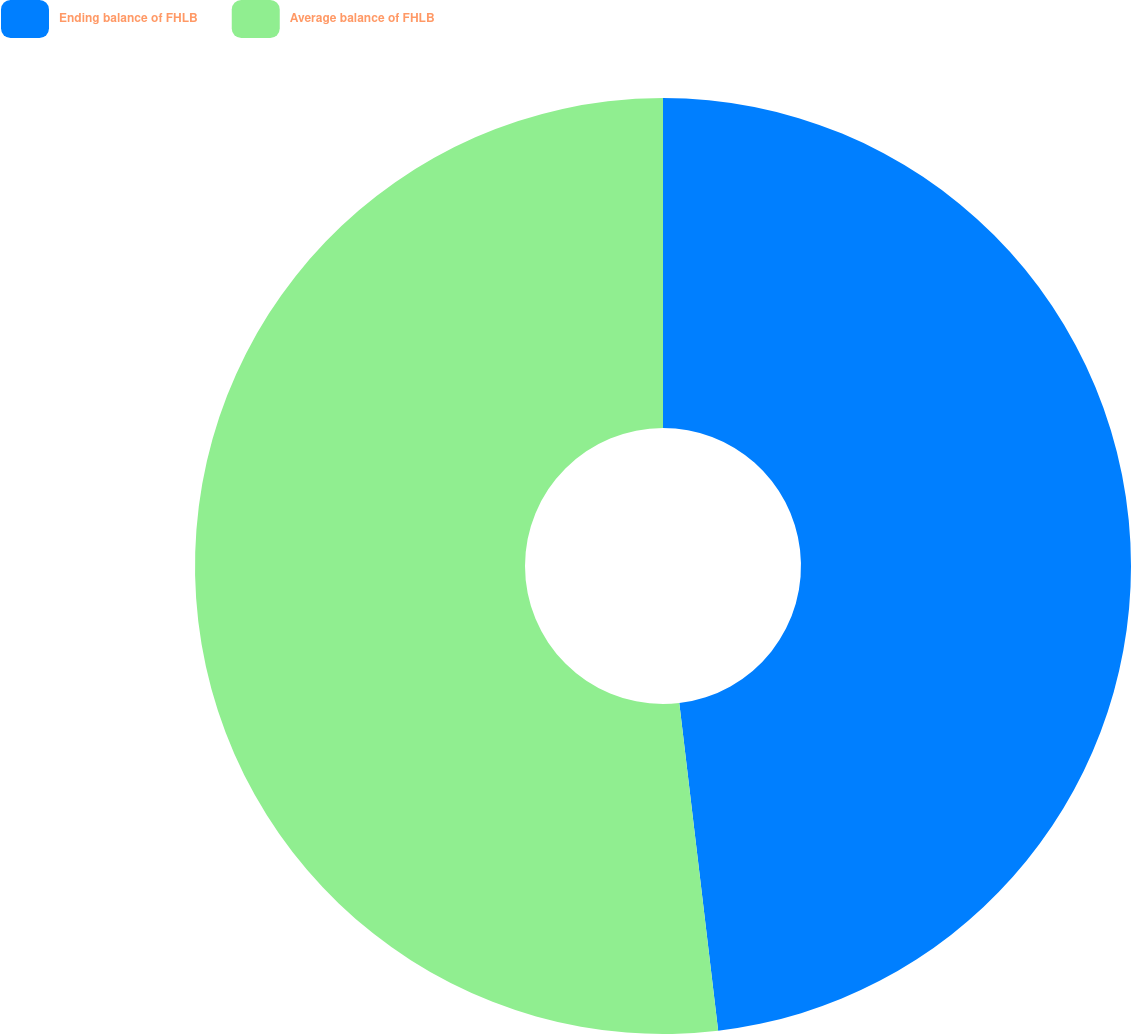<chart> <loc_0><loc_0><loc_500><loc_500><pie_chart><fcel>Ending balance of FHLB<fcel>Average balance of FHLB<nl><fcel>48.12%<fcel>51.88%<nl></chart> 